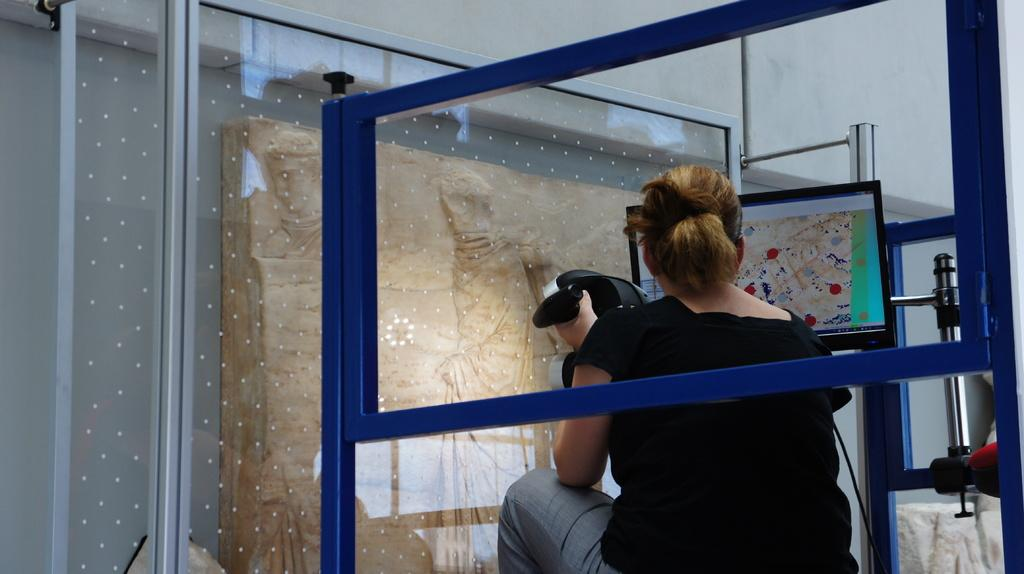What is the woman in the image doing? The woman is sitting in the image. What is the woman holding in the image? The woman is holding an object. What electronic device is present in the image? There is a television in the image. What color is the stand in the image? The stand in the image is blue. What type of container is visible in the image? There is a glass in the image. What is located on the left side of the image? There is an object on the left side of the image. What type of mint can be seen growing on the woman's head in the image? There is no mint visible in the image, nor is there any indication that the woman has mint growing on her head. 